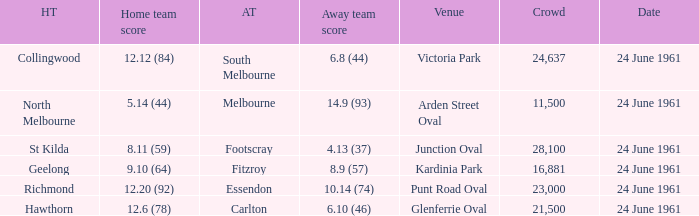What was the home team's score at the game attended by more than 24,637? 8.11 (59). 